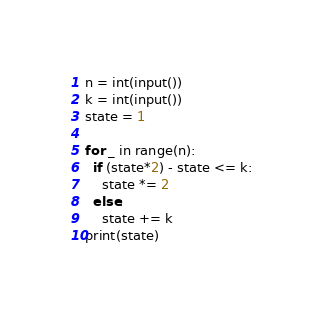Convert code to text. <code><loc_0><loc_0><loc_500><loc_500><_Python_>n = int(input())
k = int(input())
state = 1

for _ in range(n):
  if (state*2) - state <= k:
    state *= 2
  else:
    state += k
print(state)</code> 